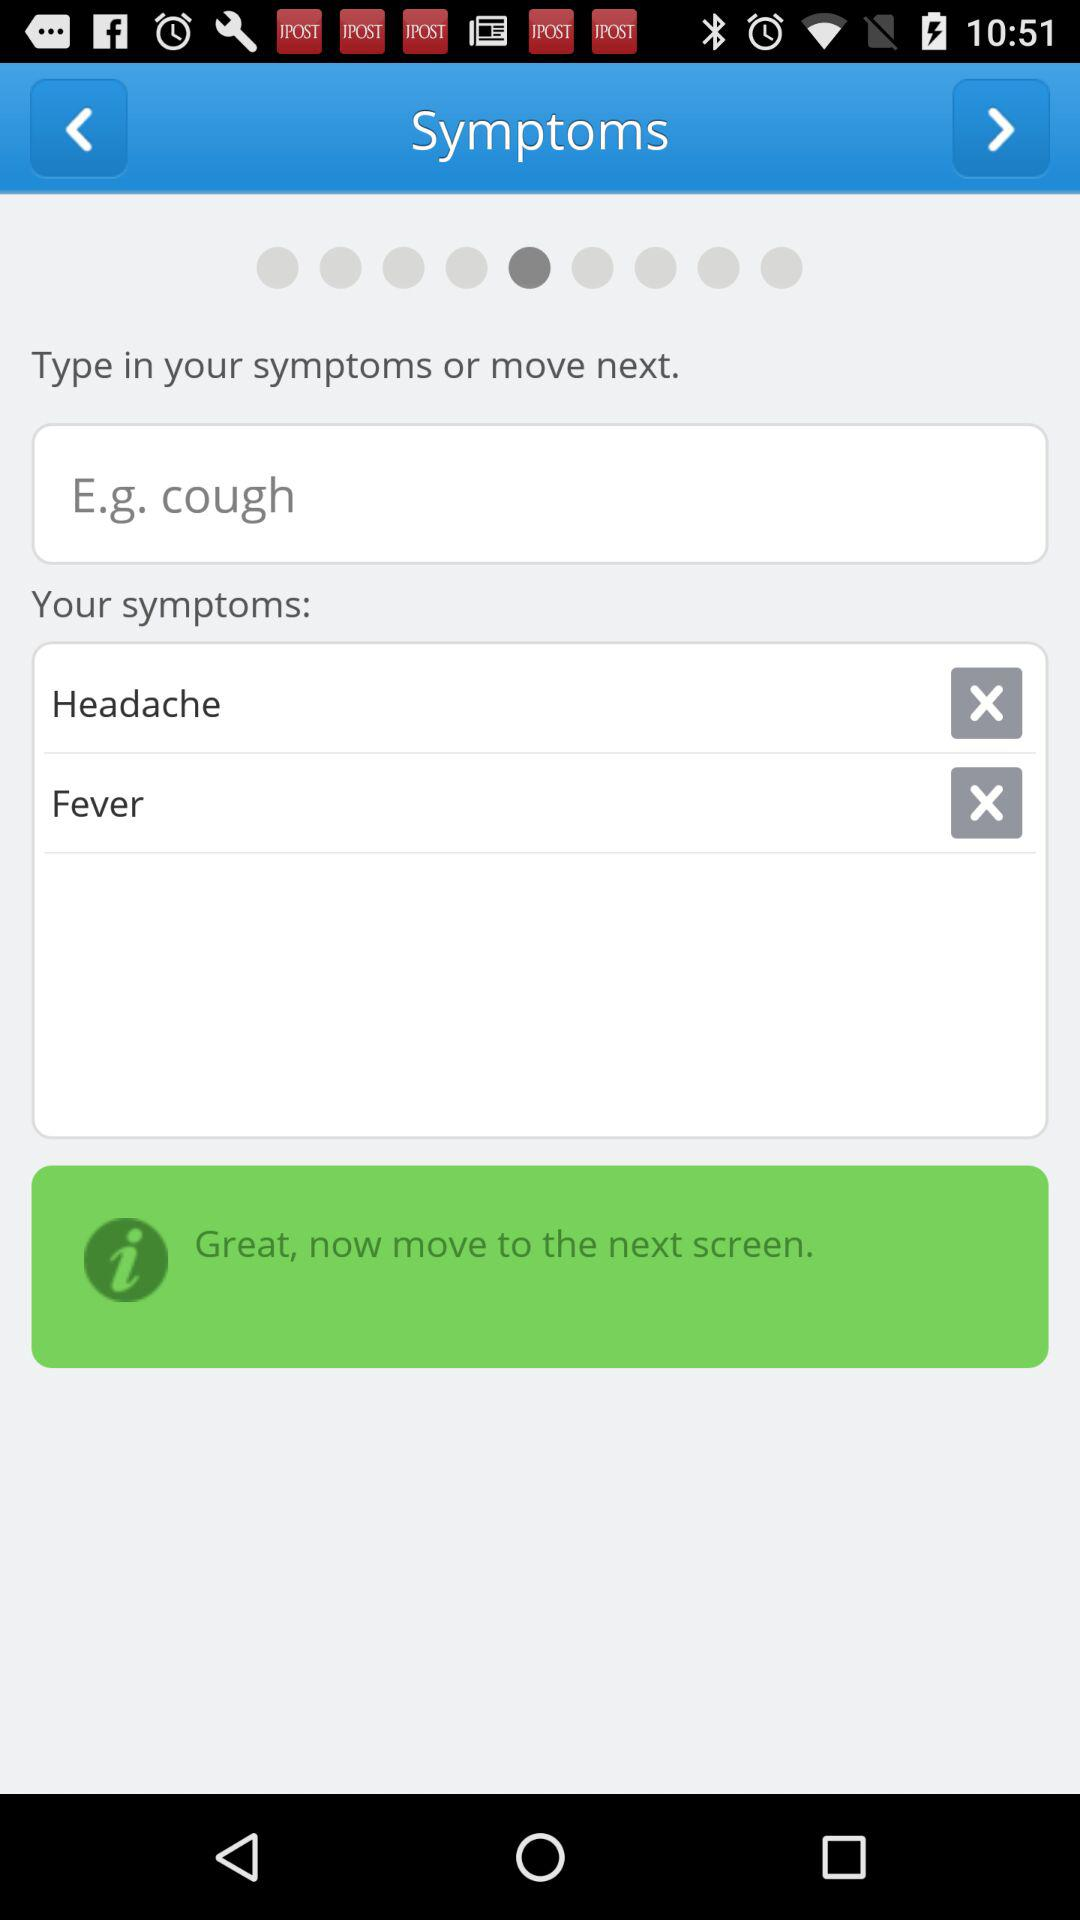How many symptoms have been entered?
Answer the question using a single word or phrase. 2 